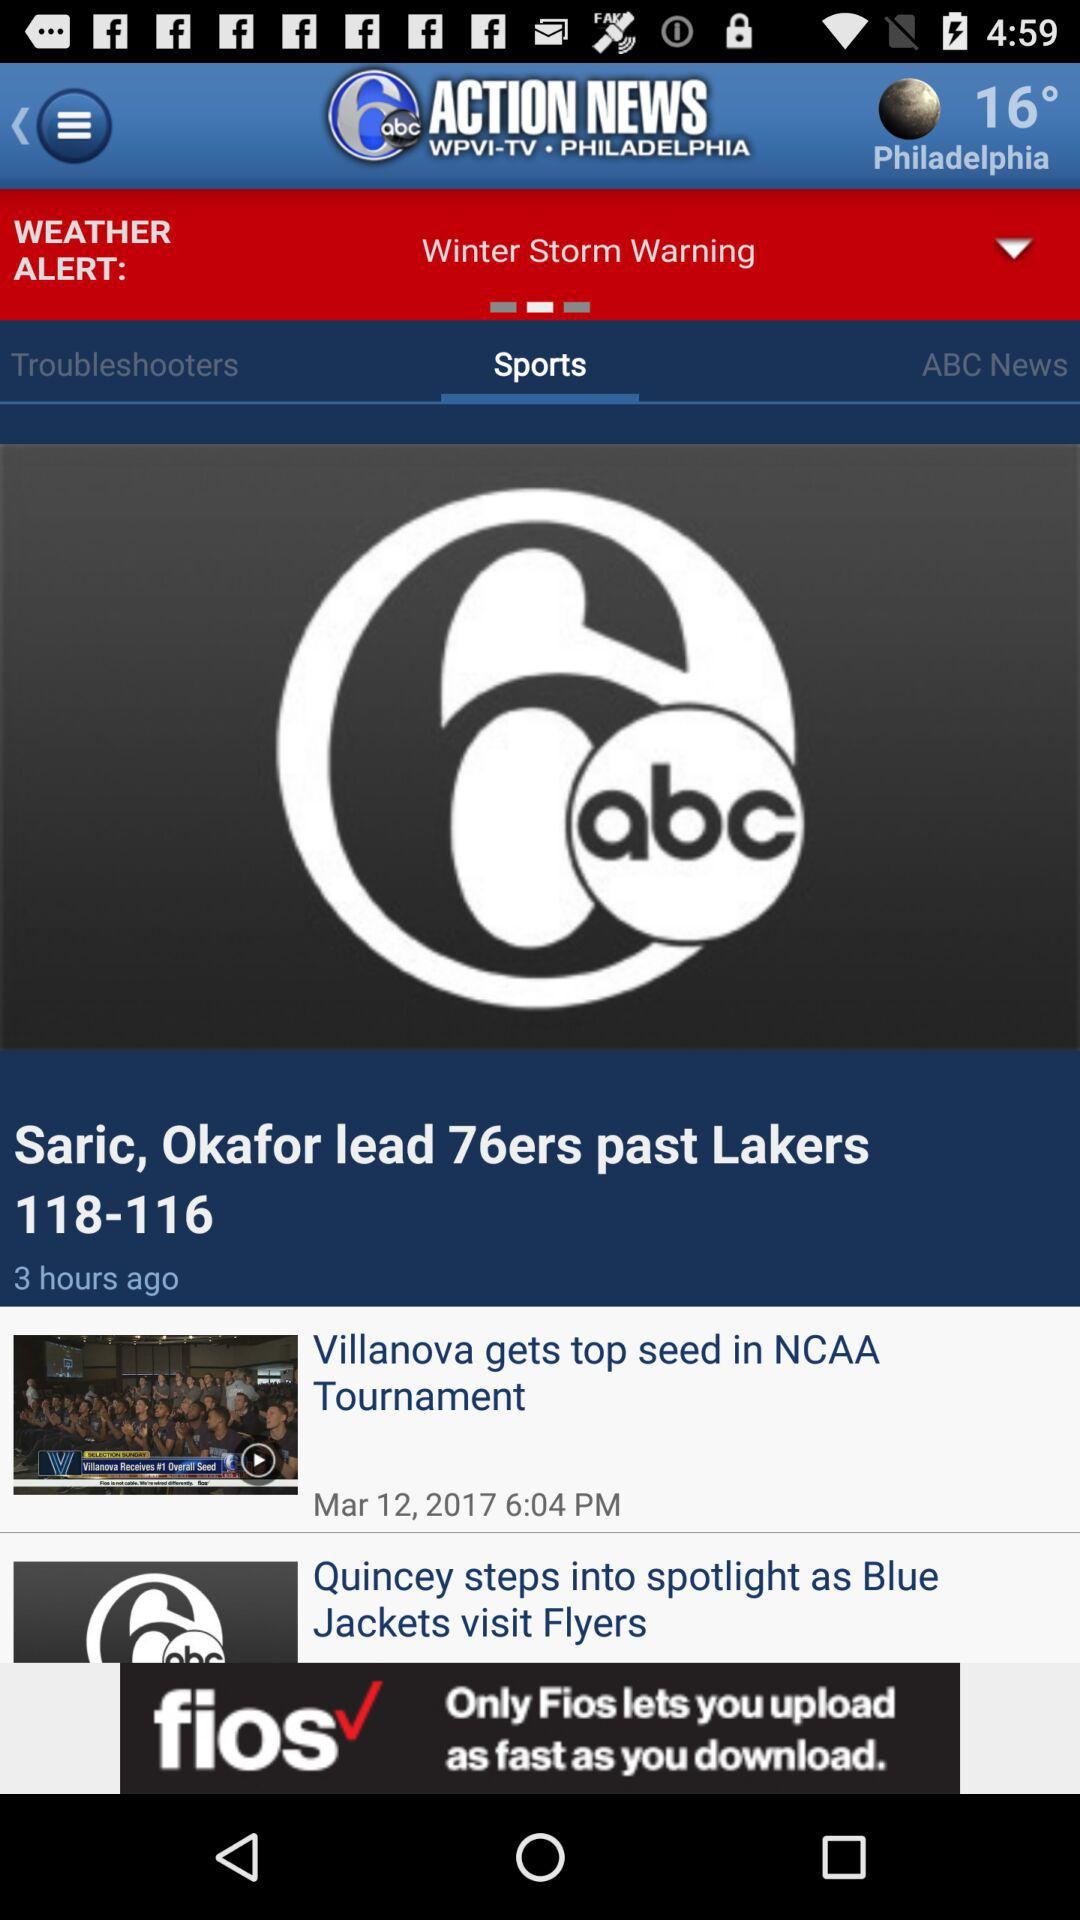When was "Saric, Okafor lead 76ers past Lakers 118-116" published? "Saric, Okafor lead 76ers past Lakers 118-116" was published 3 hours ago. 